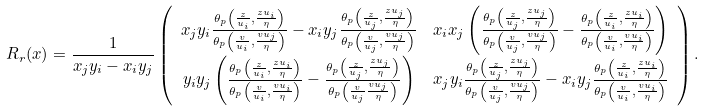Convert formula to latex. <formula><loc_0><loc_0><loc_500><loc_500>R _ { r } ( x ) = \frac { 1 } { x _ { j } y _ { i } - x _ { i } y _ { j } } & \left ( \begin{array} { c c } x _ { j } y _ { i } \frac { \theta _ { p } \left ( \frac { z } { u _ { i } } , \frac { z u _ { i } } { \eta } \right ) } { \theta _ { p } \left ( \frac { v } { u _ { i } } , \frac { v u _ { j } } { \eta } \right ) } - x _ { i } y _ { j } \frac { \theta _ { p } \left ( \frac { z } { u _ { j } } , \frac { z u _ { j } } { \eta } \right ) } { \theta _ { p } \left ( \frac { v } { u _ { j } } , \frac { v u _ { j } } { \eta } \right ) } & x _ { i } x _ { j } \left ( \frac { \theta _ { p } \left ( \frac { z } { u _ { j } } , \frac { z u _ { j } } { \eta } \right ) } { \theta _ { p } \left ( \frac { v } { u _ { j } } , \frac { v u _ { j } } { \eta } \right ) } - \frac { \theta _ { p } \left ( \frac { z } { u _ { i } } , \frac { z u _ { i } } { \eta } \right ) } { \theta _ { p } \left ( \frac { v } { u _ { i } } , \frac { v u _ { i } } { \eta } \right ) } \right ) \\ y _ { i } y _ { j } \left ( \frac { \theta _ { p } \left ( \frac { z } { u _ { i } } , \frac { z u _ { i } } { \eta } \right ) } { \theta _ { p } \left ( \frac { v } { u _ { i } } , \frac { v u _ { i } } { \eta } \right ) } - \frac { \theta _ { p } \left ( \frac { z } { u _ { j } } , \frac { z u _ { j } } { \eta } \right ) } { \theta _ { p } \left ( \frac { v } { u _ { j } } \frac { v u _ { j } } { \eta } \right ) } \right ) & x _ { j } y _ { i } \frac { \theta _ { p } \left ( \frac { z } { u _ { j } } , \frac { z u _ { j } } { \eta } \right ) } { \theta _ { p } \left ( \frac { v } { u _ { j } } , \frac { v u _ { j } } { \eta } \right ) } - x _ { i } y _ { j } \frac { \theta _ { p } \left ( \frac { z } { u _ { i } } , \frac { z u _ { i } } { \eta } \right ) } { \theta _ { p } \left ( \frac { v } { u _ { i } } , \frac { v u _ { i } } { \eta } \right ) } \end{array} \right ) .</formula> 